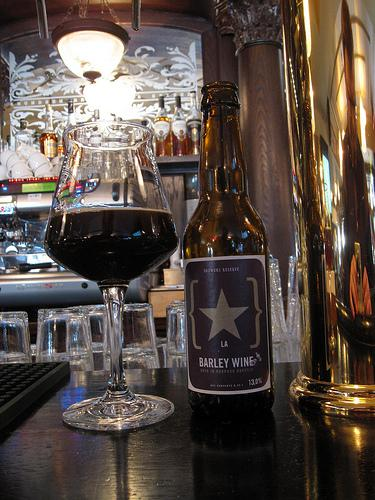Question: what color is the bottle?
Choices:
A. The bottle is green.
B. The bottle is brown.
C. The bottle is clear.
D. The bottle is white.
Answer with the letter. Answer: B Question: when was this picture taken?
Choices:
A. Yesterday.
B. It was taken in the day time.
C. Today.
D. Noon.
Answer with the letter. Answer: B Question: what is in the picture?
Choices:
A. Wine glasses.
B. Table.
C. A bottle of wine is in the picture.
D. People drinking wine.
Answer with the letter. Answer: C Question: who is in the picture?
Choices:
A. A man.
B. Nobody is in the picture.
C. A woman.
D. A boy.
Answer with the letter. Answer: B 